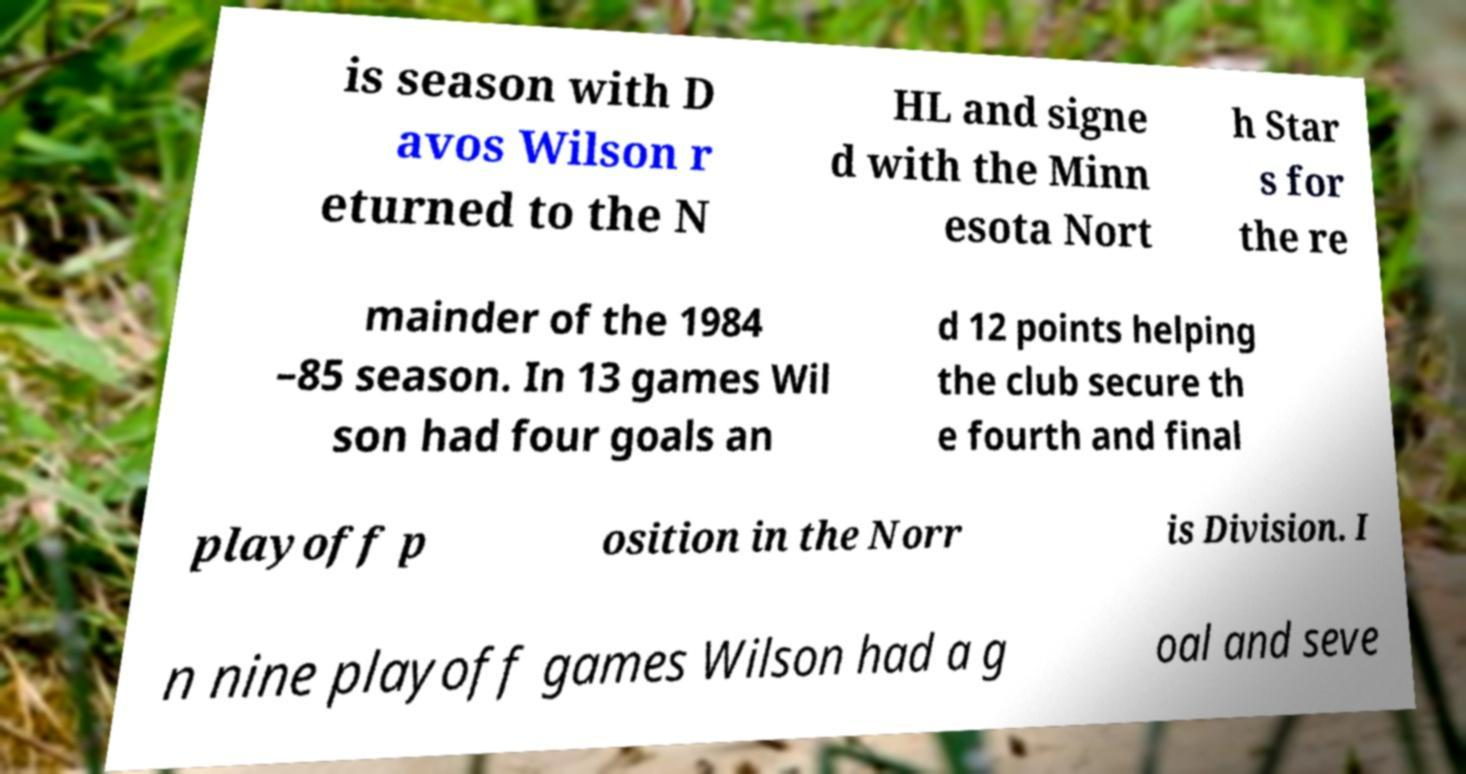Can you accurately transcribe the text from the provided image for me? is season with D avos Wilson r eturned to the N HL and signe d with the Minn esota Nort h Star s for the re mainder of the 1984 –85 season. In 13 games Wil son had four goals an d 12 points helping the club secure th e fourth and final playoff p osition in the Norr is Division. I n nine playoff games Wilson had a g oal and seve 